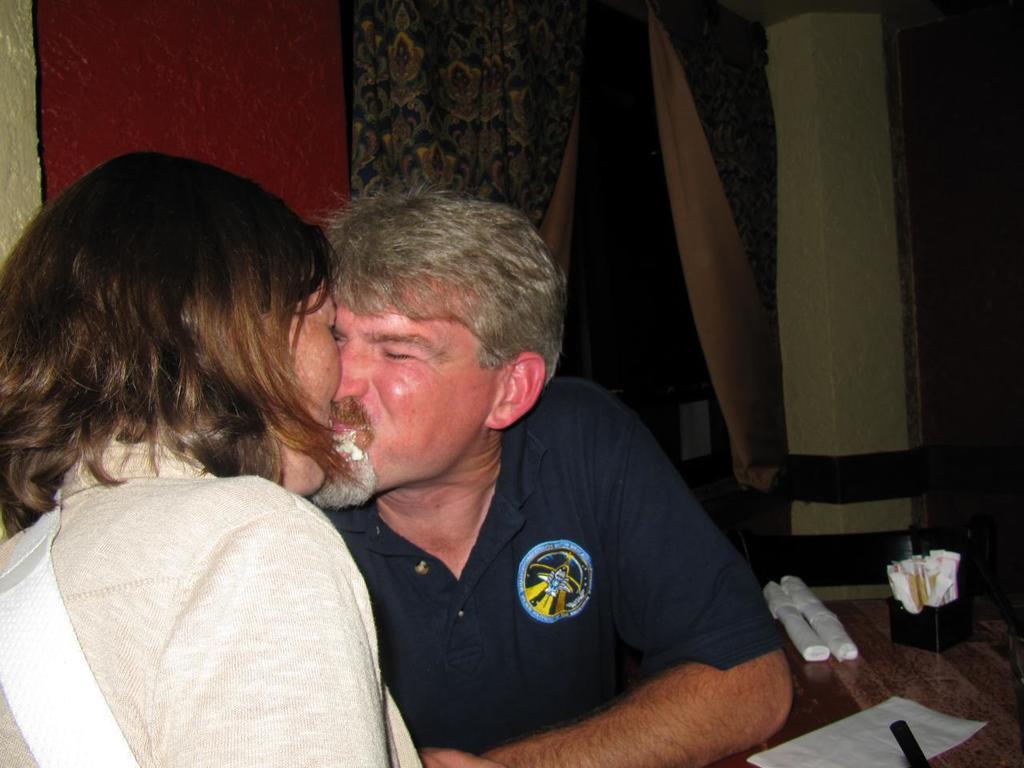Describe this image in one or two sentences. In this image I can see a woman wearing white dress and a man wearing black dress are siting on chairs in front of a table and on the table I can see few tissue papers and few other objects. In the background I can see the wall, the window and the curtain. 